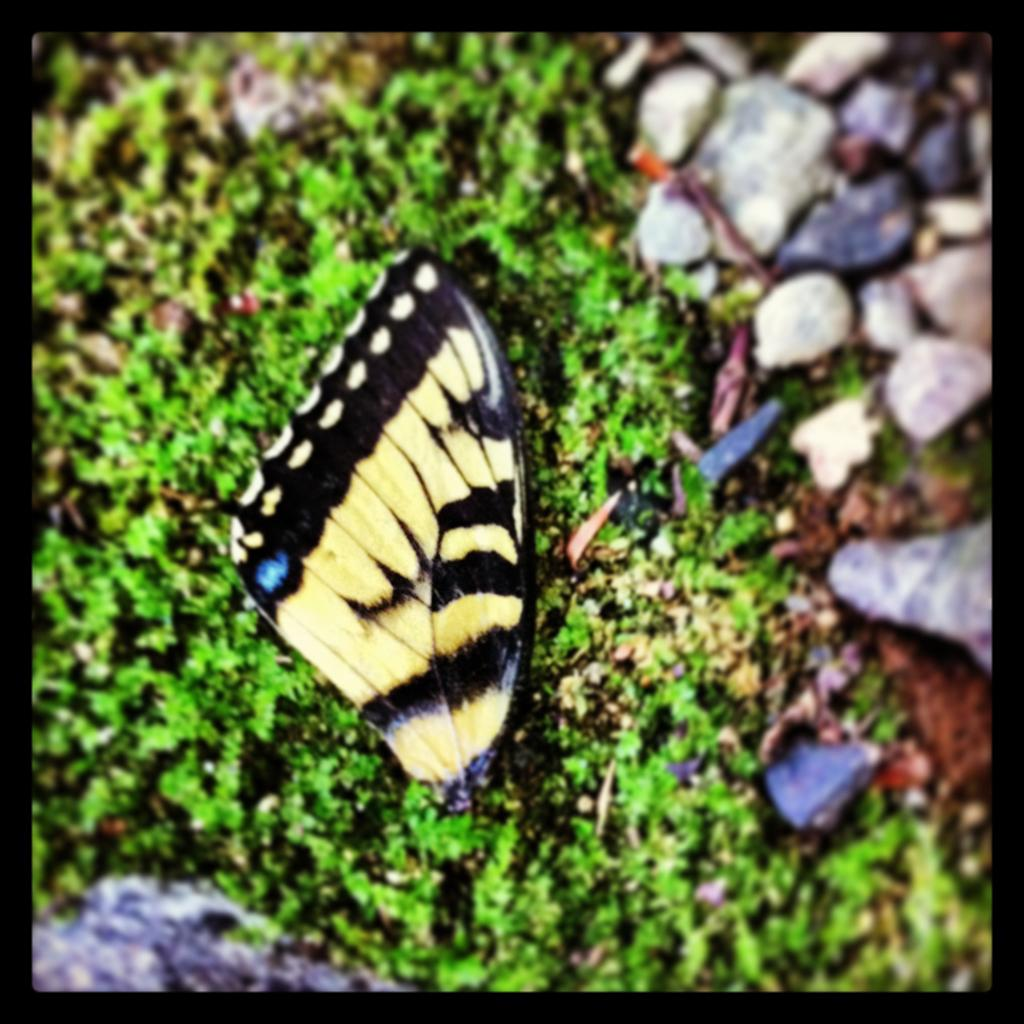What is the main subject of the image? There is a butterfly in the image. Where is the butterfly located? The butterfly is on the grass. What colors can be seen on the butterfly? The butterfly has black and yellow colors. What else can be seen in the image besides the butterfly? There are stones visible to the right in the image. What type of alley can be seen in the image? There is no alley present in the image; it features a butterfly on the grass and stones to the right. What role does the celery play in the image? There is no celery present in the image. 